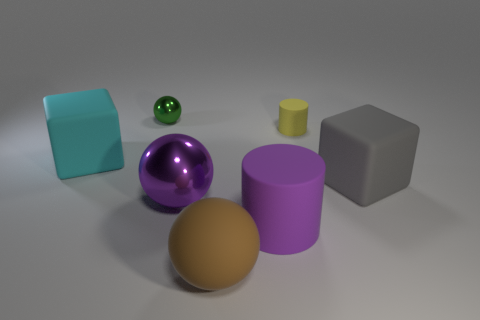What is the material of the cylinder in front of the small yellow cylinder?
Give a very brief answer. Rubber. Do the big brown matte thing and the purple metal object have the same shape?
Provide a succinct answer. Yes. There is another ball that is the same material as the tiny ball; what is its color?
Keep it short and to the point. Purple. What number of things are spheres that are behind the brown thing or brown rubber things?
Your response must be concise. 3. There is a yellow matte cylinder behind the brown rubber object; what size is it?
Ensure brevity in your answer.  Small. Do the gray cube and the ball that is behind the big gray rubber thing have the same size?
Offer a terse response. No. What is the color of the metal ball in front of the rubber cube in front of the cyan rubber block?
Provide a succinct answer. Purple. How many other things are the same color as the large cylinder?
Provide a succinct answer. 1. How big is the cyan object?
Give a very brief answer. Large. Are there more blocks on the left side of the small shiny object than big rubber things right of the gray matte cube?
Give a very brief answer. Yes. 